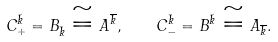<formula> <loc_0><loc_0><loc_500><loc_500>C _ { + } ^ { \bar { k } } = B _ { \bar { k } } \cong A ^ { \overline { k } } , \quad C _ { - } ^ { \bar { k } } = B ^ { \bar { k } } \cong A _ { \overline { k } } .</formula> 